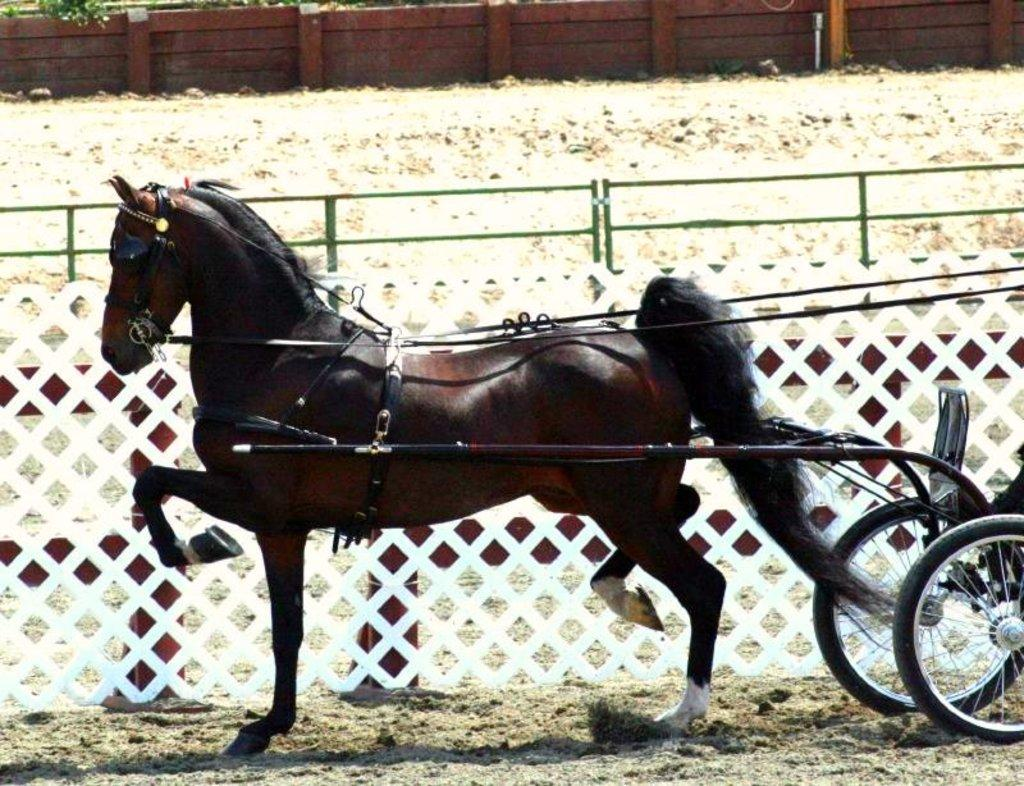What type of vehicle is in the image? There is a horse cart in the image. What can be seen in the background of the image? There is a mesh and a wall in the background of the image. Is there a volcano erupting in the background of the image? No, there is no volcano present in the image. Can you see a cemetery in the background of the image? No, there is no cemetery present in the image. 